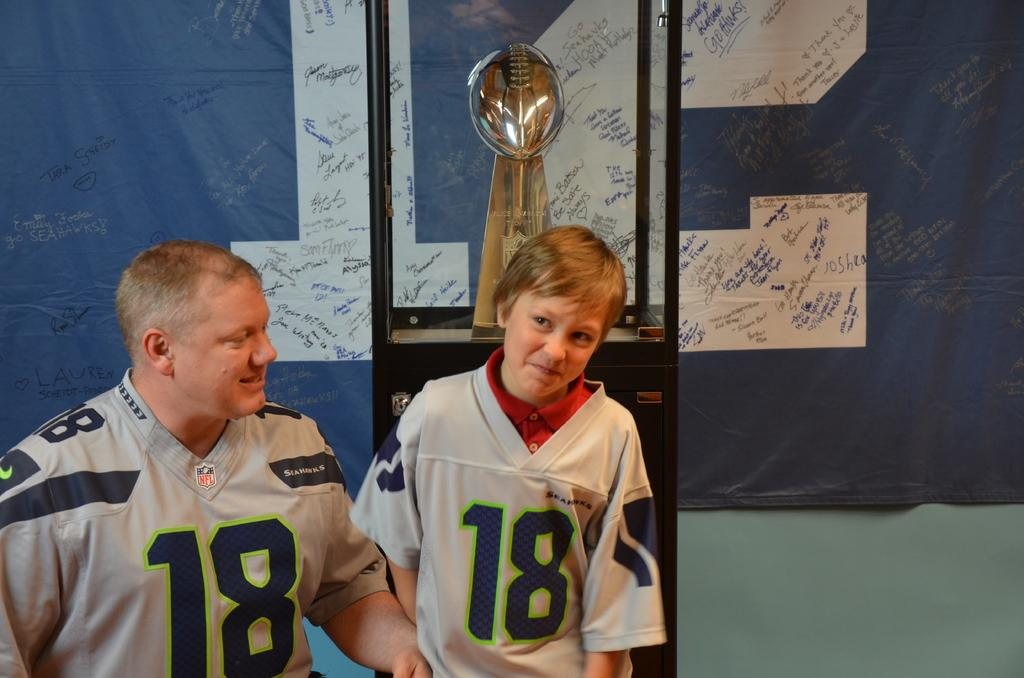<image>
Share a concise interpretation of the image provided. a man and boy in number 18 jerseys standing in front of a football trophy 